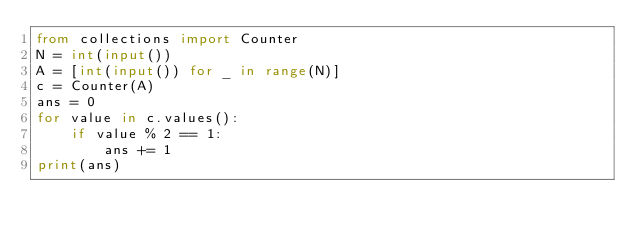<code> <loc_0><loc_0><loc_500><loc_500><_Python_>from collections import Counter
N = int(input())
A = [int(input()) for _ in range(N)]
c = Counter(A)
ans = 0
for value in c.values():
    if value % 2 == 1:
        ans += 1
print(ans)
</code> 